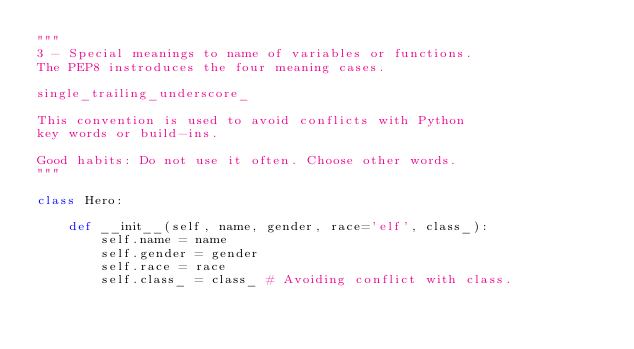<code> <loc_0><loc_0><loc_500><loc_500><_Python_>"""
3 - Special meanings to name of variables or functions.
The PEP8 instroduces the four meaning cases.

single_trailing_underscore_

This convention is used to avoid conflicts with Python
key words or build-ins.

Good habits: Do not use it often. Choose other words.
"""

class Hero:

    def __init__(self, name, gender, race='elf', class_):
        self.name = name
        self.gender = gender
        self.race = race
        self.class_ = class_ # Avoiding conflict with class.
</code> 